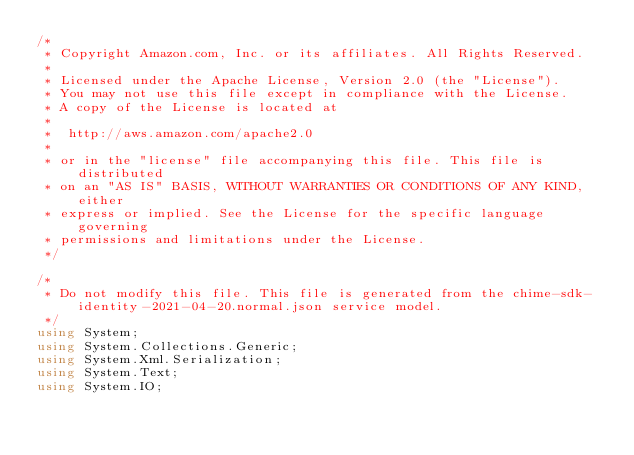<code> <loc_0><loc_0><loc_500><loc_500><_C#_>/*
 * Copyright Amazon.com, Inc. or its affiliates. All Rights Reserved.
 * 
 * Licensed under the Apache License, Version 2.0 (the "License").
 * You may not use this file except in compliance with the License.
 * A copy of the License is located at
 * 
 *  http://aws.amazon.com/apache2.0
 * 
 * or in the "license" file accompanying this file. This file is distributed
 * on an "AS IS" BASIS, WITHOUT WARRANTIES OR CONDITIONS OF ANY KIND, either
 * express or implied. See the License for the specific language governing
 * permissions and limitations under the License.
 */

/*
 * Do not modify this file. This file is generated from the chime-sdk-identity-2021-04-20.normal.json service model.
 */
using System;
using System.Collections.Generic;
using System.Xml.Serialization;
using System.Text;
using System.IO;</code> 